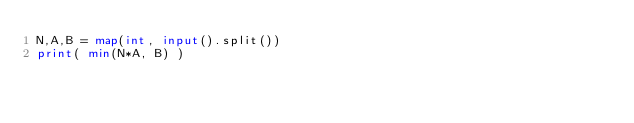Convert code to text. <code><loc_0><loc_0><loc_500><loc_500><_Python_>N,A,B = map(int, input().split())
print( min(N*A, B) )</code> 